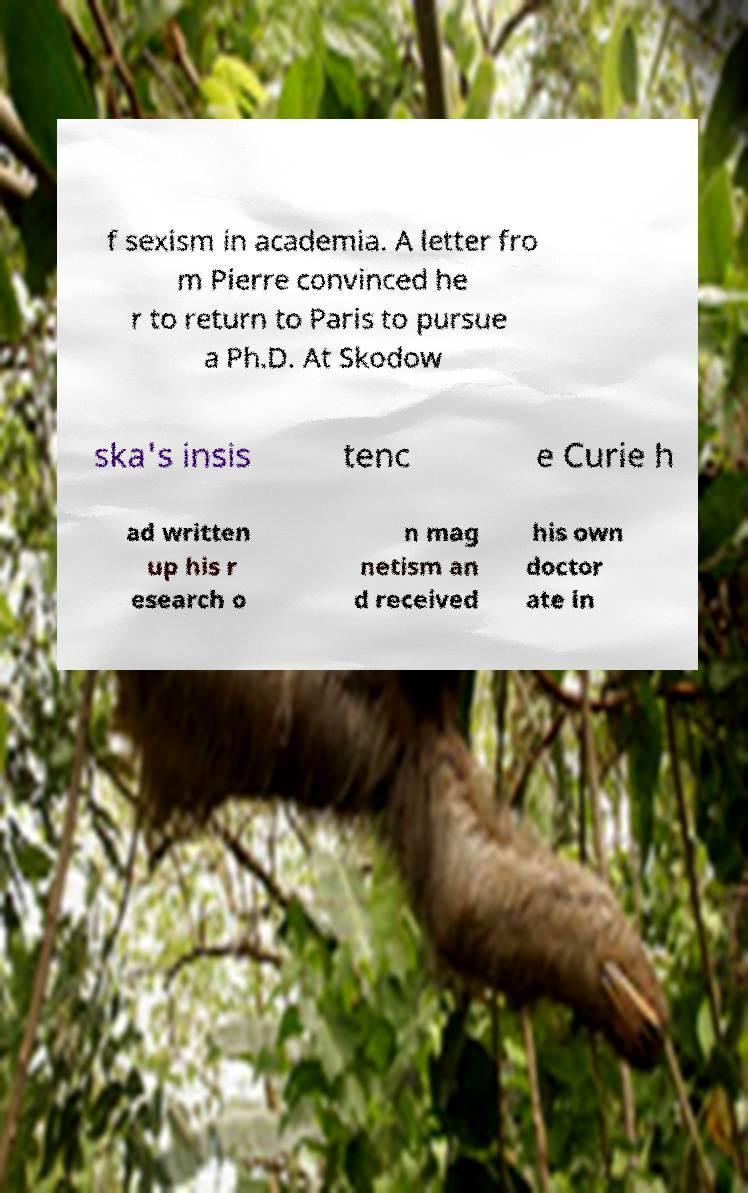There's text embedded in this image that I need extracted. Can you transcribe it verbatim? f sexism in academia. A letter fro m Pierre convinced he r to return to Paris to pursue a Ph.D. At Skodow ska's insis tenc e Curie h ad written up his r esearch o n mag netism an d received his own doctor ate in 